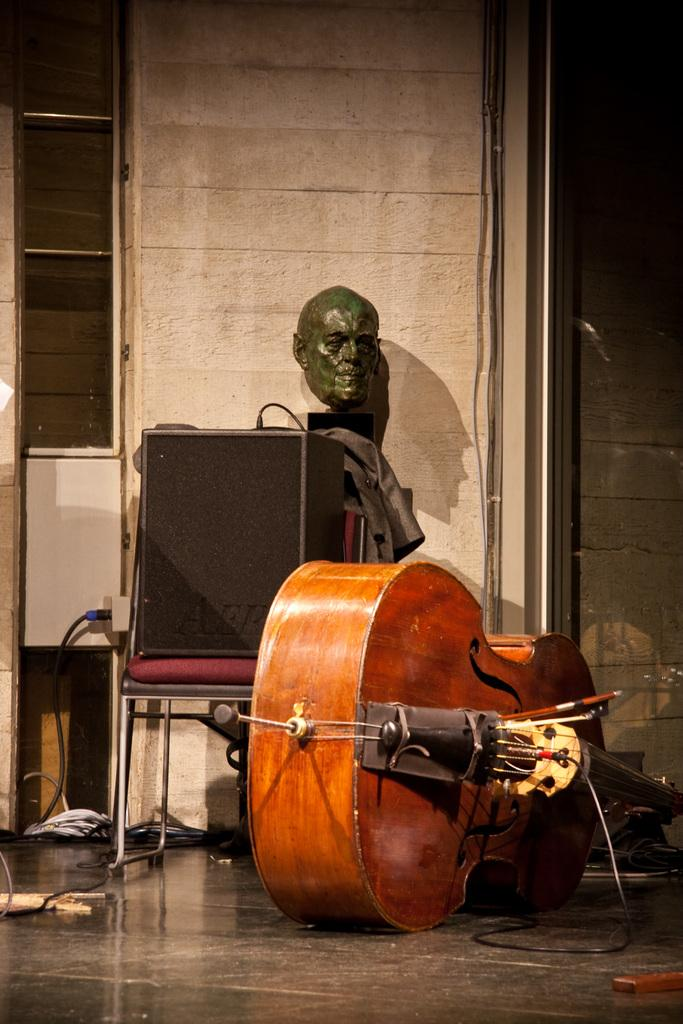What object in the image is used for making music? There is a musical instrument in the image. Can you describe the object on the chair in the background? There is a speaker on a chair in the background. What is hanging on the wall in the background? There is a mask attached to the wall in the background. What color is the wall in the image? The wall is in cream color. What is the opinion of the wrist in the image? There is no wrist present in the image, so it is not possible to determine its opinion. 